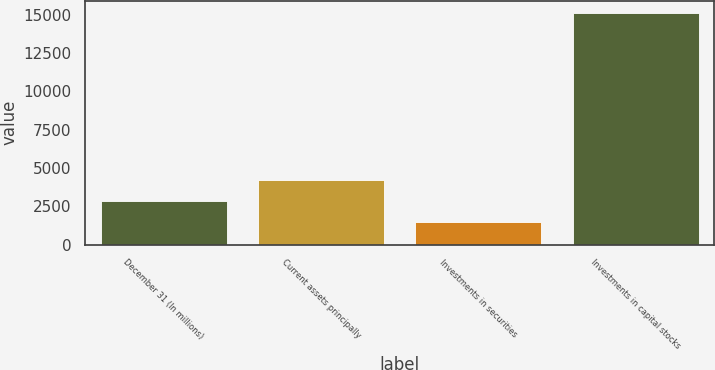<chart> <loc_0><loc_0><loc_500><loc_500><bar_chart><fcel>December 31 (In millions)<fcel>Current assets principally<fcel>Investments in securities<fcel>Investments in capital stocks<nl><fcel>2851.2<fcel>4215.4<fcel>1487<fcel>15129<nl></chart> 